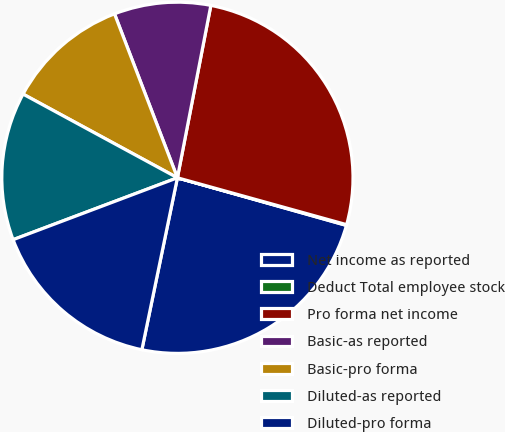<chart> <loc_0><loc_0><loc_500><loc_500><pie_chart><fcel>Net income as reported<fcel>Deduct Total employee stock<fcel>Pro forma net income<fcel>Basic-as reported<fcel>Basic-pro forma<fcel>Diluted-as reported<fcel>Diluted-pro forma<nl><fcel>23.87%<fcel>0.07%<fcel>26.25%<fcel>8.88%<fcel>11.26%<fcel>13.64%<fcel>16.02%<nl></chart> 